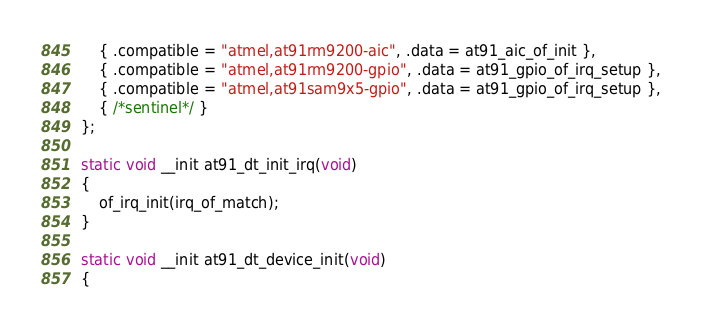<code> <loc_0><loc_0><loc_500><loc_500><_C_>	{ .compatible = "atmel,at91rm9200-aic", .data = at91_aic_of_init },
	{ .compatible = "atmel,at91rm9200-gpio", .data = at91_gpio_of_irq_setup },
	{ .compatible = "atmel,at91sam9x5-gpio", .data = at91_gpio_of_irq_setup },
	{ /*sentinel*/ }
};

static void __init at91_dt_init_irq(void)
{
	of_irq_init(irq_of_match);
}

static void __init at91_dt_device_init(void)
{</code> 